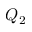Convert formula to latex. <formula><loc_0><loc_0><loc_500><loc_500>Q _ { 2 }</formula> 